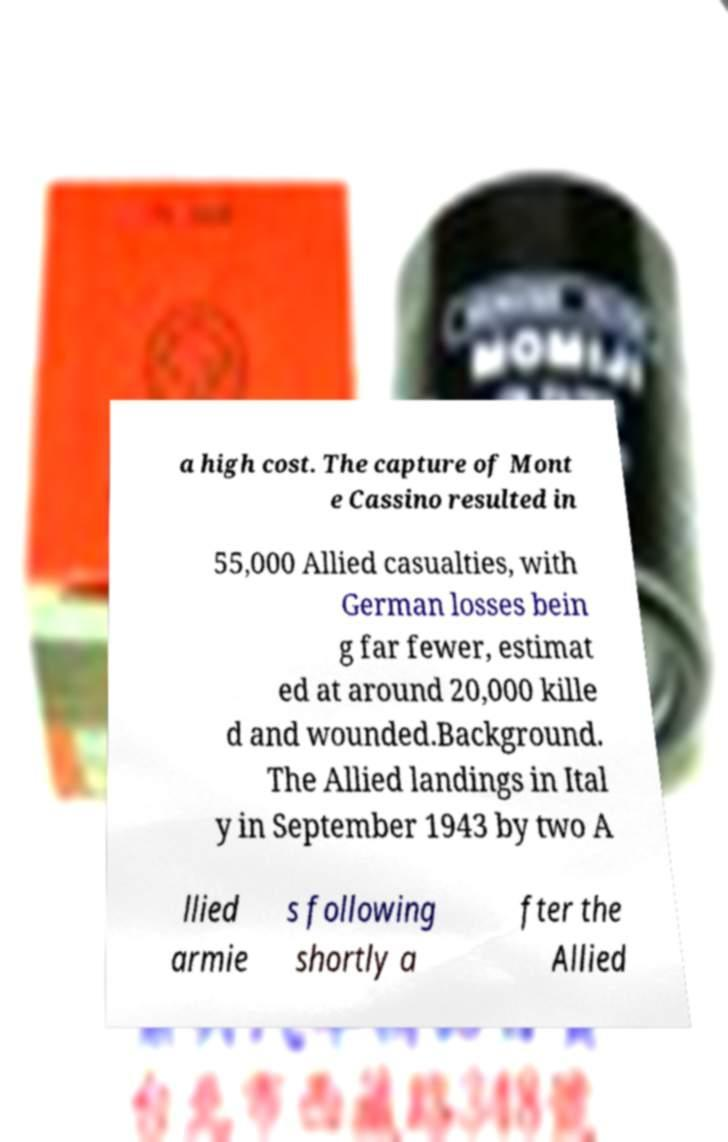Please read and relay the text visible in this image. What does it say? a high cost. The capture of Mont e Cassino resulted in 55,000 Allied casualties, with German losses bein g far fewer, estimat ed at around 20,000 kille d and wounded.Background. The Allied landings in Ital y in September 1943 by two A llied armie s following shortly a fter the Allied 